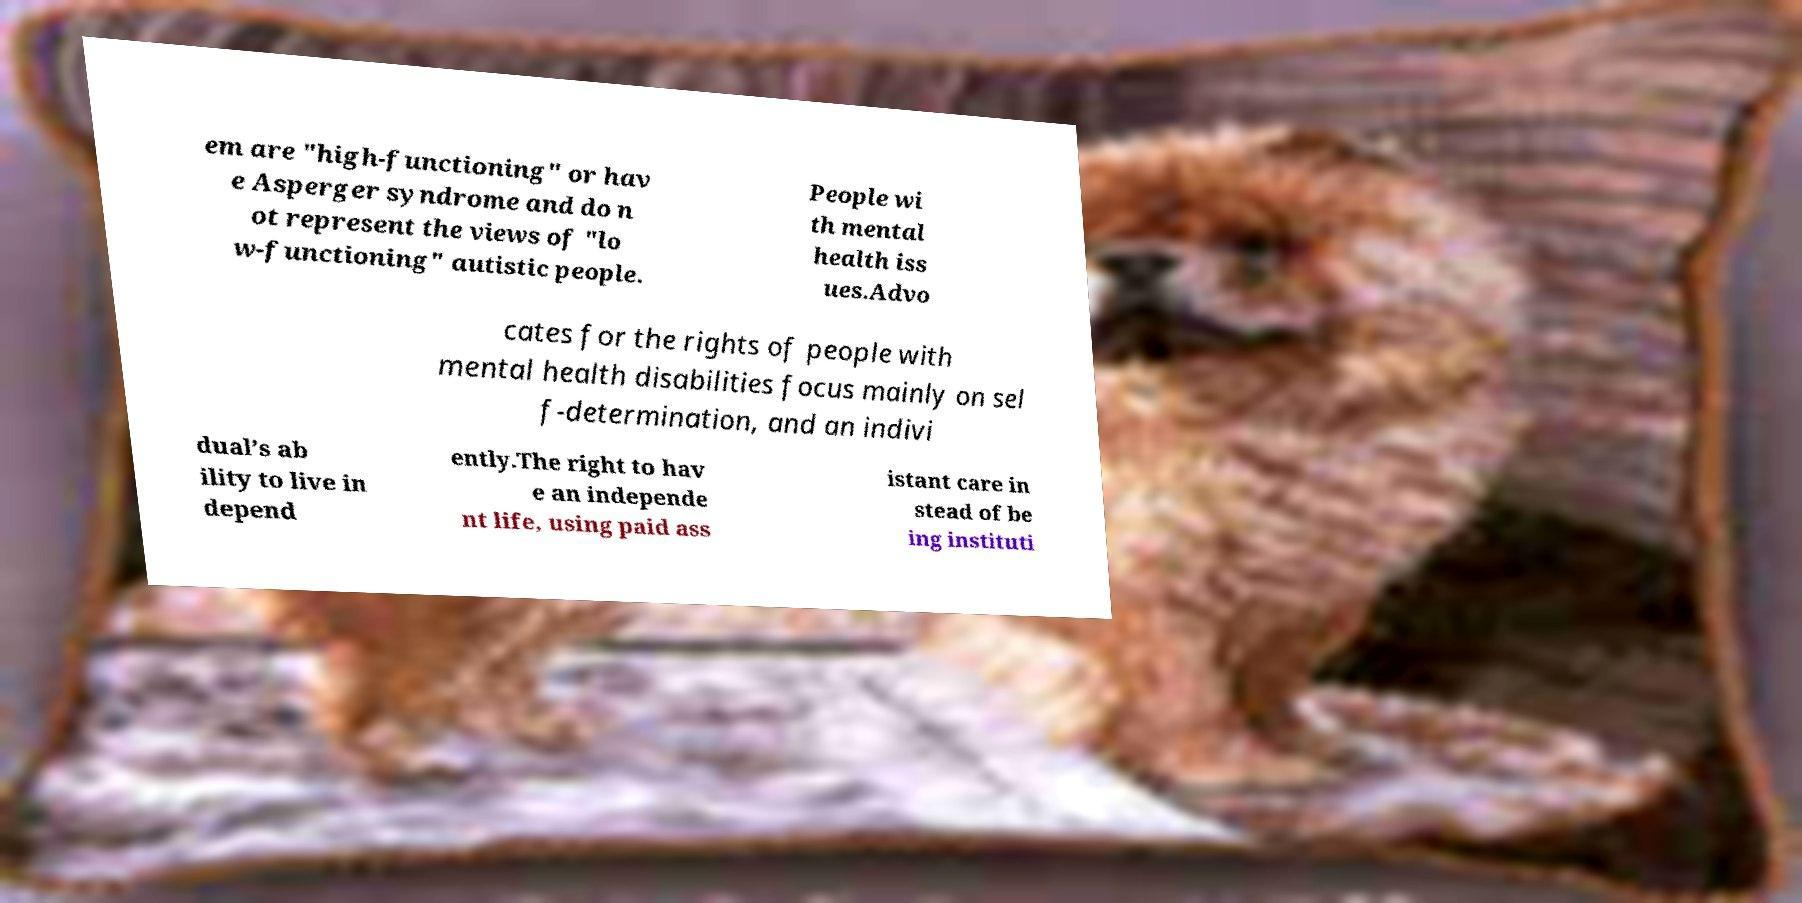Please identify and transcribe the text found in this image. em are "high-functioning" or hav e Asperger syndrome and do n ot represent the views of "lo w-functioning" autistic people. People wi th mental health iss ues.Advo cates for the rights of people with mental health disabilities focus mainly on sel f-determination, and an indivi dual’s ab ility to live in depend ently.The right to hav e an independe nt life, using paid ass istant care in stead of be ing instituti 